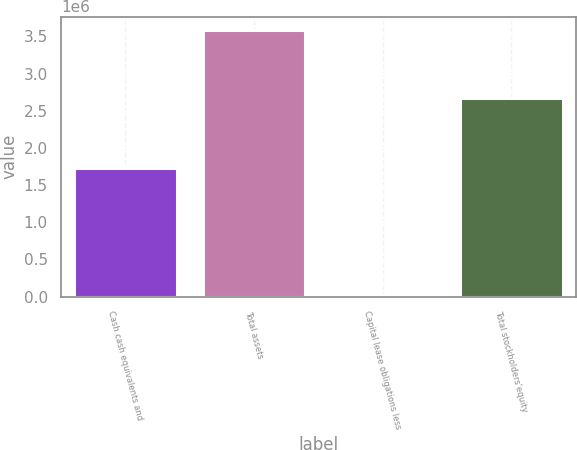Convert chart. <chart><loc_0><loc_0><loc_500><loc_500><bar_chart><fcel>Cash cash equivalents and<fcel>Total assets<fcel>Capital lease obligations less<fcel>Total stockholders'equity<nl><fcel>1.72823e+06<fcel>3.58592e+06<fcel>24450<fcel>2.66514e+06<nl></chart> 